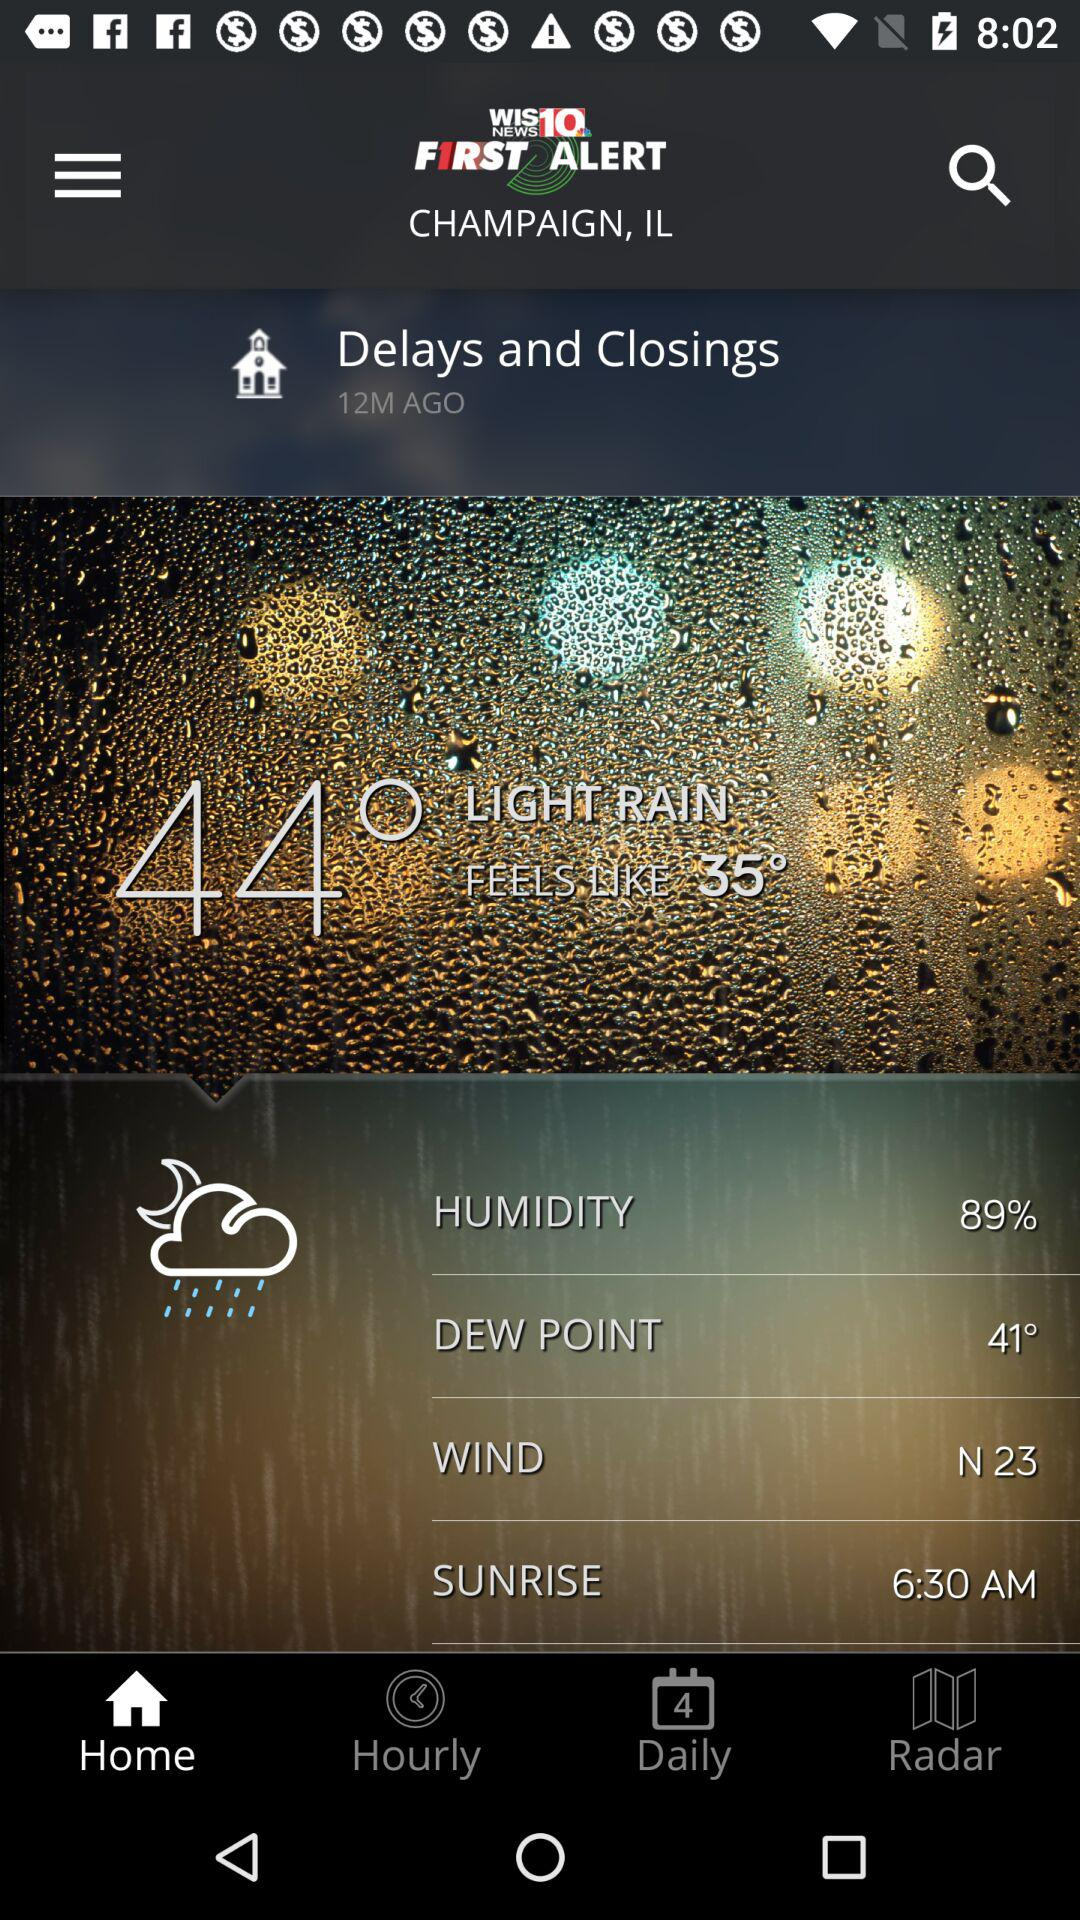How many degrees warmer is the current temperature than the feels like temperature?
Answer the question using a single word or phrase. 9° 